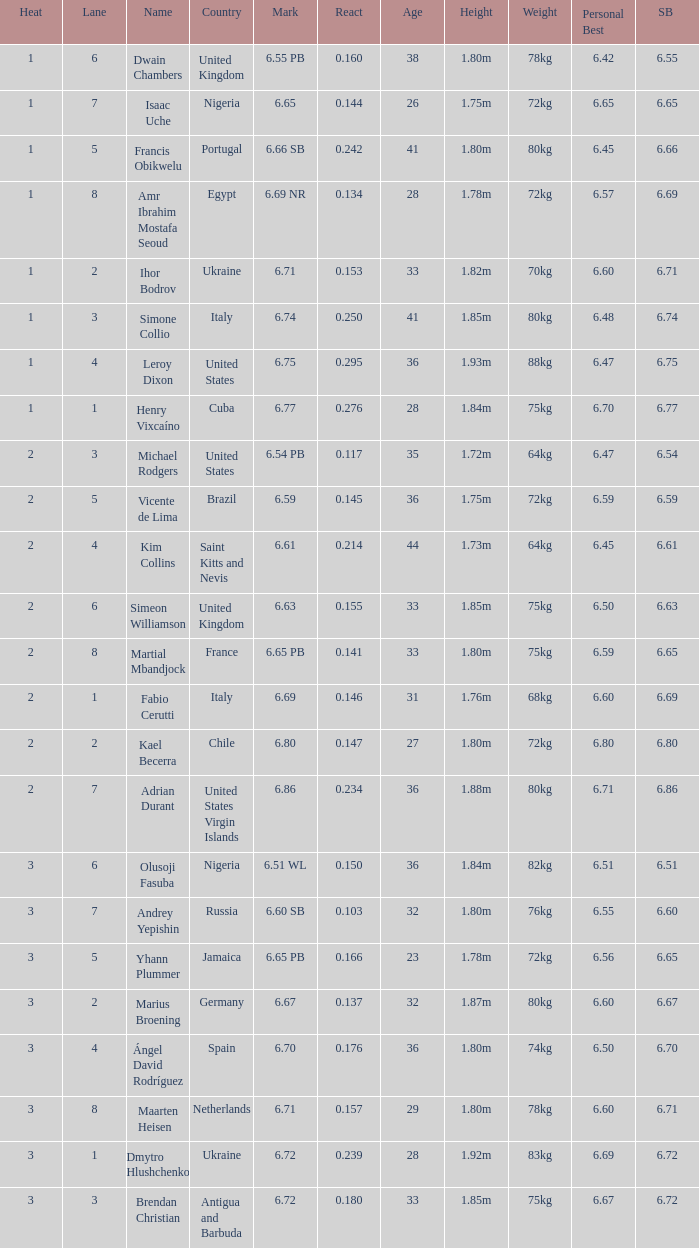What is Mark, when Name is Dmytro Hlushchenko? 6.72. 